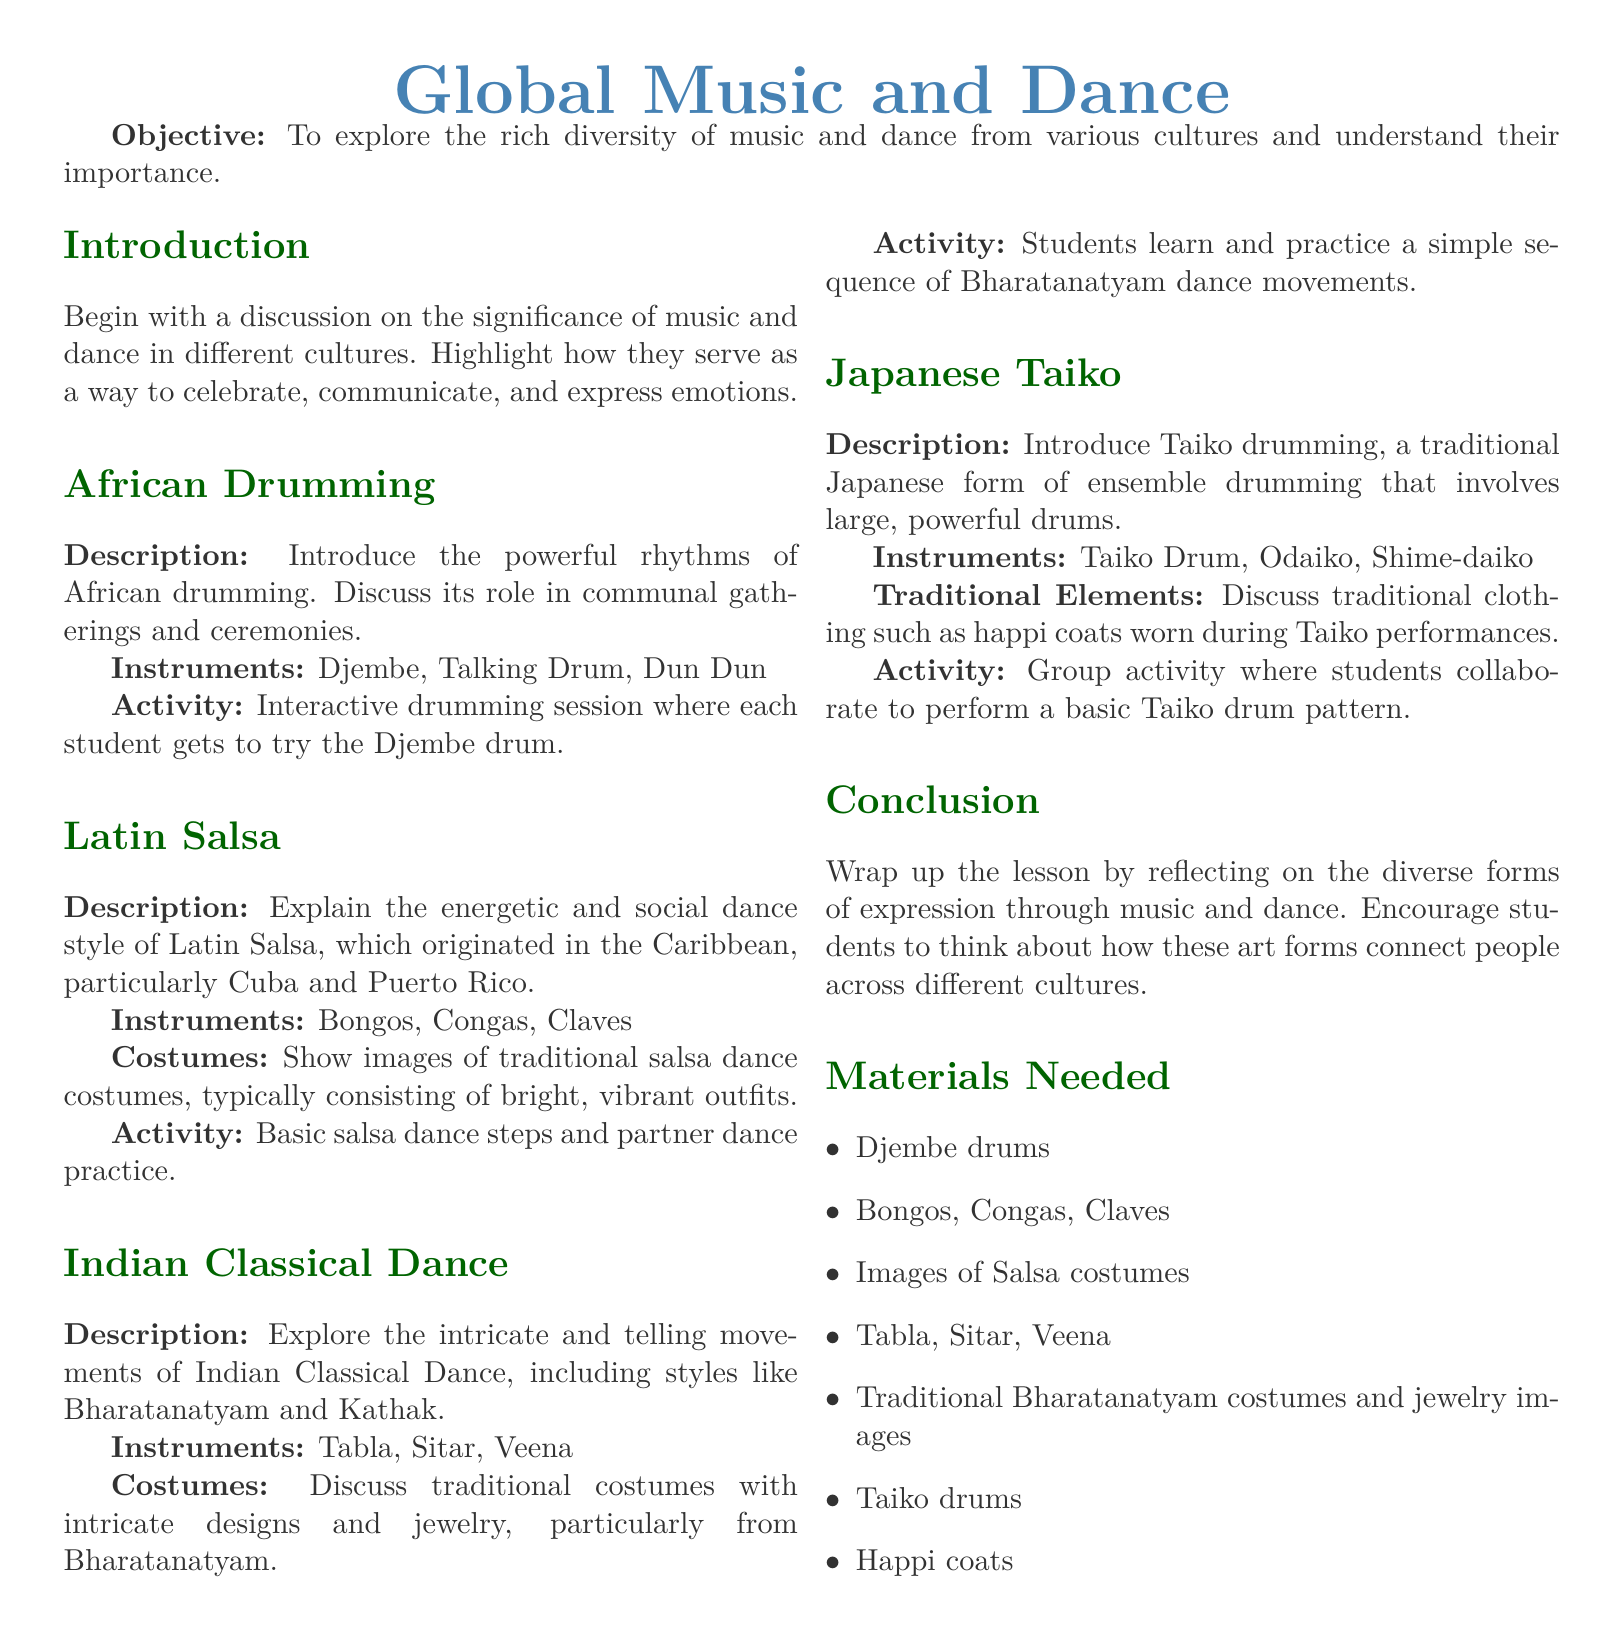What is the objective of the lesson? The objective is to explore the rich diversity of music and dance from various cultures and understand their importance.
Answer: To explore the rich diversity of music and dance from various cultures and understand their importance Which instruments are associated with African drumming? The instruments listed for African drumming are specifically three types: Djembe, Talking Drum, and Dun Dun.
Answer: Djembe, Talking Drum, Dun Dun What traditional costumes are discussed in the Indian Classical Dance section? The lesson plan mentions traditional costumes with intricate designs and jewelry specifically from Bharatanatyam.
Answer: Traditional costumes with intricate designs and jewelry from Bharatanatyam What is one of the activities for Latin Salsa? The activity for Latin Salsa involves practicing basic salsa dance steps and partner dance practice.
Answer: Basic salsa dance steps and partner dance practice Which instruments are used in Japanese Taiko? The instruments listed for Japanese Taiko include Taiko Drum, Odaiko, and Shime-daiko.
Answer: Taiko Drum, Odaiko, Shime-daiko What is the main focus of the conclusion in the lesson plan? The conclusion emphasizes reflecting on diverse forms of expression through music and dance and connecting people across cultures.
Answer: Reflecting on the diverse forms of expression through music and dance How many main sections are there in the lesson plan? There are five main sections covering different cultural music and dance styles.
Answer: Five What type of dance does the Bharatanatyam sequence represent? Bharatanatyam is a style of Indian Classical Dance.
Answer: Indian Classical Dance 